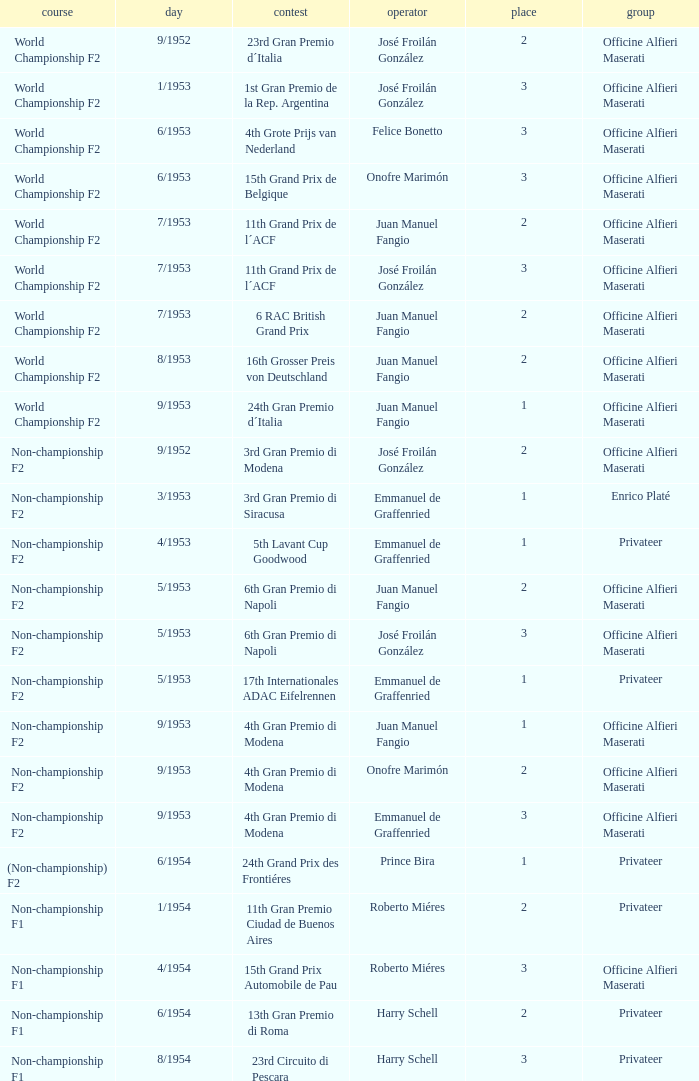What date has the class of non-championship f2 as well as a driver name josé froilán gonzález that has a position larger than 2? 5/1953. 